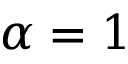Convert formula to latex. <formula><loc_0><loc_0><loc_500><loc_500>\alpha = 1</formula> 